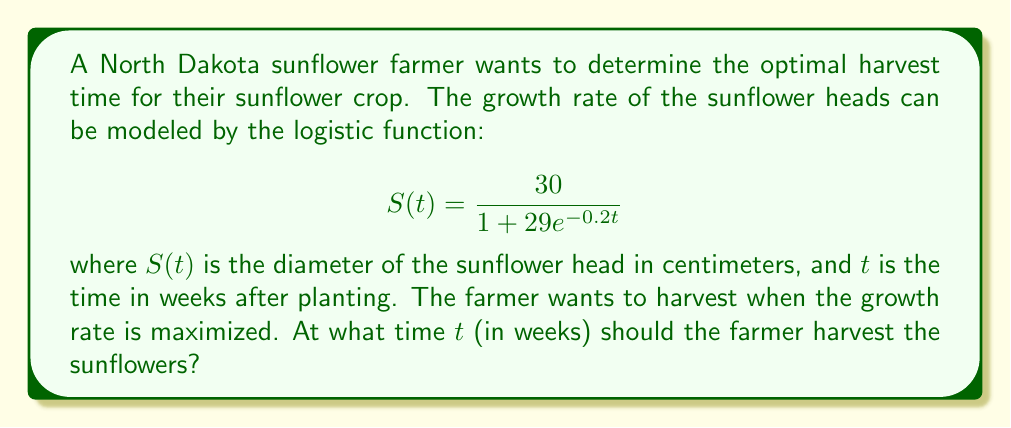Provide a solution to this math problem. To find the optimal harvest time, we need to determine when the growth rate is at its maximum. This occurs at the inflection point of the logistic function.

1. The general logistic function is given by:
   $$f(t) = \frac{L}{1 + ae^{-kt}}$$
   where $L$ is the carrying capacity, $a$ is a constant, and $k$ is the growth rate.

2. For our specific function:
   $L = 30$, $a = 29$, and $k = 0.2$

3. The inflection point of a logistic function occurs at:
   $$t = \frac{\ln(a)}{k}$$

4. Substituting our values:
   $$t = \frac{\ln(29)}{0.2}$$

5. Calculate:
   $$t = \frac{3.3673}{0.2} = 16.8365$$

6. Round to the nearest week:
   $t \approx 17$ weeks

Therefore, the farmer should harvest the sunflowers approximately 17 weeks after planting to maximize the growth rate.
Answer: 17 weeks 